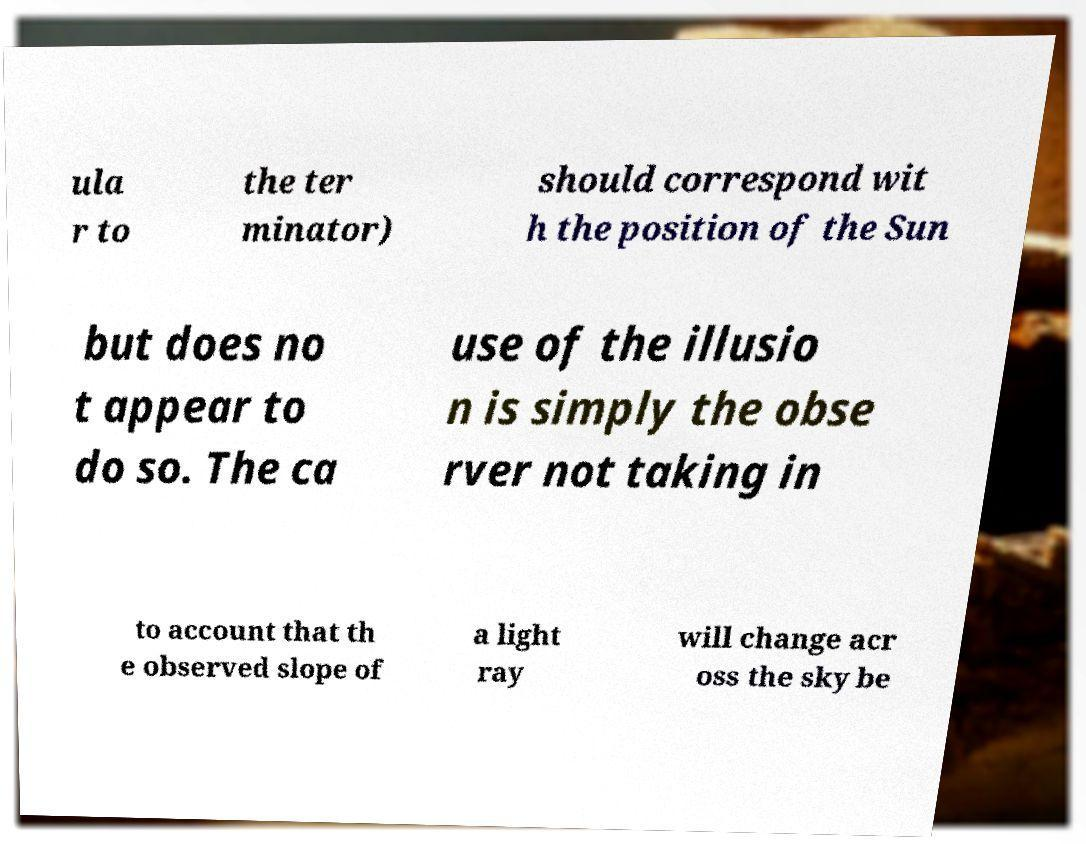Can you read and provide the text displayed in the image?This photo seems to have some interesting text. Can you extract and type it out for me? ula r to the ter minator) should correspond wit h the position of the Sun but does no t appear to do so. The ca use of the illusio n is simply the obse rver not taking in to account that th e observed slope of a light ray will change acr oss the sky be 